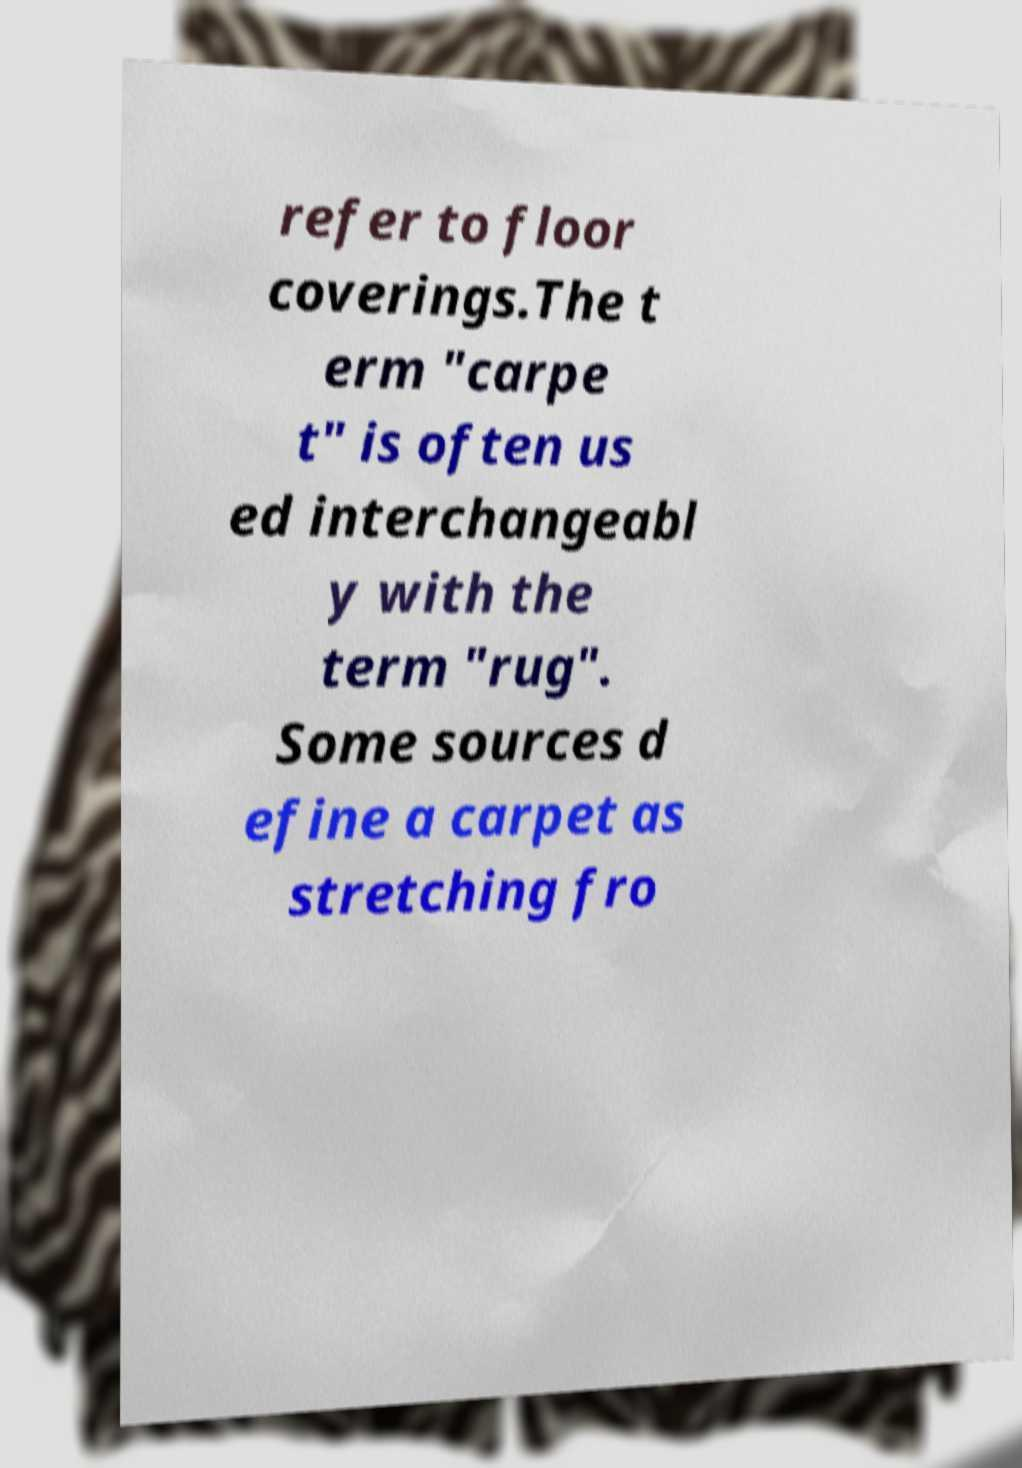There's text embedded in this image that I need extracted. Can you transcribe it verbatim? refer to floor coverings.The t erm "carpe t" is often us ed interchangeabl y with the term "rug". Some sources d efine a carpet as stretching fro 